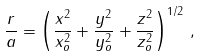<formula> <loc_0><loc_0><loc_500><loc_500>\frac { r } { a } = \left ( \frac { x ^ { 2 } } { x _ { o } ^ { 2 } } + \frac { y ^ { 2 } } { y _ { o } ^ { 2 } } + \frac { z ^ { 2 } } { z _ { o } ^ { 2 } } \right ) ^ { 1 / 2 } \, ,</formula> 